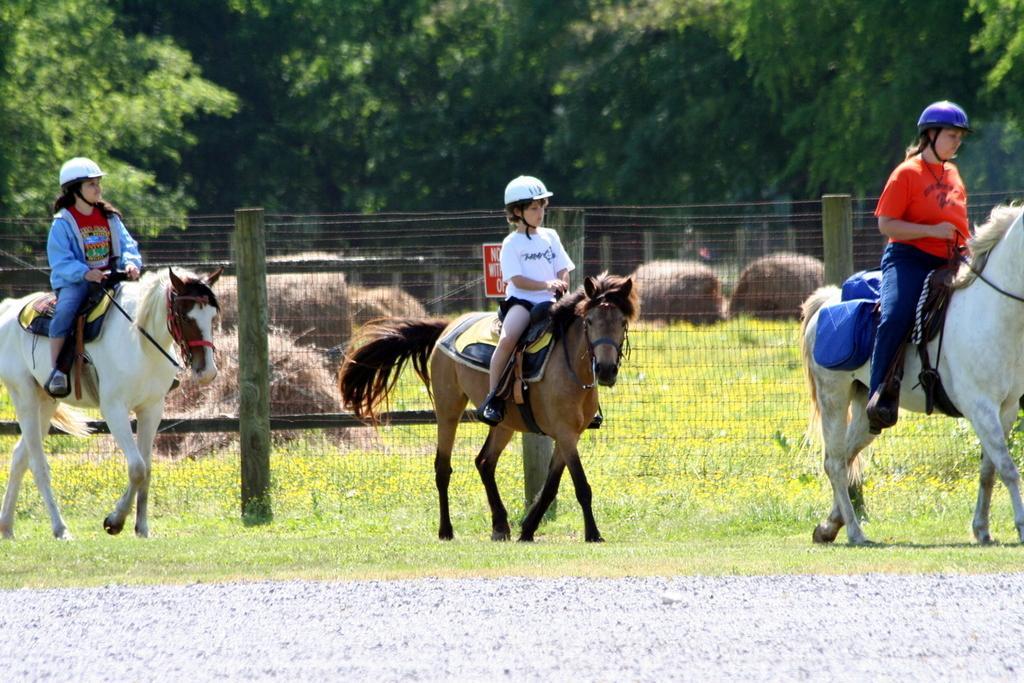How would you summarize this image in a sentence or two? In the middle a little boy is riding the horse it is in brown color. In the left side a girl is riding the horse, it is in white color. In the long back side there are trees. 